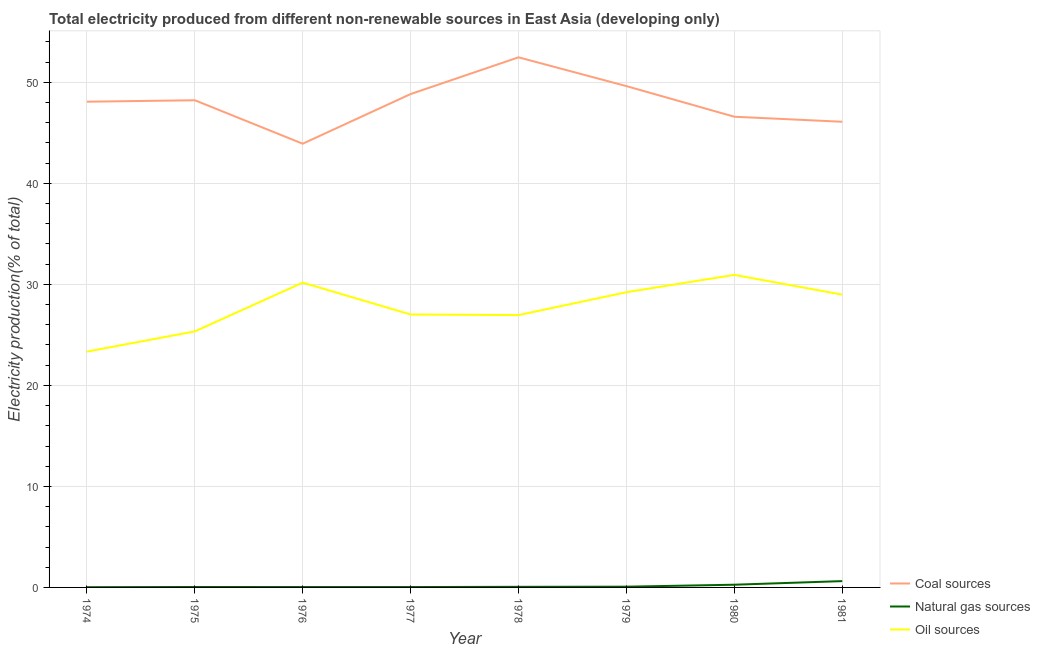Is the number of lines equal to the number of legend labels?
Your answer should be compact. Yes. What is the percentage of electricity produced by natural gas in 1976?
Offer a very short reply. 0.04. Across all years, what is the maximum percentage of electricity produced by coal?
Your answer should be compact. 52.48. Across all years, what is the minimum percentage of electricity produced by coal?
Offer a very short reply. 43.92. In which year was the percentage of electricity produced by natural gas maximum?
Your response must be concise. 1981. In which year was the percentage of electricity produced by natural gas minimum?
Your response must be concise. 1974. What is the total percentage of electricity produced by oil sources in the graph?
Your answer should be compact. 221.99. What is the difference between the percentage of electricity produced by oil sources in 1980 and that in 1981?
Provide a short and direct response. 1.96. What is the difference between the percentage of electricity produced by oil sources in 1981 and the percentage of electricity produced by natural gas in 1974?
Provide a succinct answer. 28.96. What is the average percentage of electricity produced by natural gas per year?
Your answer should be compact. 0.15. In the year 1975, what is the difference between the percentage of electricity produced by natural gas and percentage of electricity produced by coal?
Keep it short and to the point. -48.18. In how many years, is the percentage of electricity produced by natural gas greater than 36 %?
Keep it short and to the point. 0. What is the ratio of the percentage of electricity produced by natural gas in 1974 to that in 1981?
Your response must be concise. 0.04. Is the percentage of electricity produced by natural gas in 1978 less than that in 1979?
Your answer should be compact. Yes. Is the difference between the percentage of electricity produced by natural gas in 1974 and 1975 greater than the difference between the percentage of electricity produced by coal in 1974 and 1975?
Your answer should be very brief. Yes. What is the difference between the highest and the second highest percentage of electricity produced by natural gas?
Offer a very short reply. 0.36. What is the difference between the highest and the lowest percentage of electricity produced by oil sources?
Give a very brief answer. 7.6. In how many years, is the percentage of electricity produced by coal greater than the average percentage of electricity produced by coal taken over all years?
Your response must be concise. 5. Is it the case that in every year, the sum of the percentage of electricity produced by coal and percentage of electricity produced by natural gas is greater than the percentage of electricity produced by oil sources?
Offer a very short reply. Yes. Is the percentage of electricity produced by coal strictly greater than the percentage of electricity produced by oil sources over the years?
Offer a terse response. Yes. Is the percentage of electricity produced by natural gas strictly less than the percentage of electricity produced by coal over the years?
Keep it short and to the point. Yes. How many lines are there?
Your answer should be compact. 3. What is the difference between two consecutive major ticks on the Y-axis?
Keep it short and to the point. 10. Does the graph contain any zero values?
Give a very brief answer. No. Where does the legend appear in the graph?
Ensure brevity in your answer.  Bottom right. How many legend labels are there?
Give a very brief answer. 3. How are the legend labels stacked?
Your answer should be very brief. Vertical. What is the title of the graph?
Your answer should be compact. Total electricity produced from different non-renewable sources in East Asia (developing only). What is the label or title of the X-axis?
Your answer should be very brief. Year. What is the label or title of the Y-axis?
Your response must be concise. Electricity production(% of total). What is the Electricity production(% of total) in Coal sources in 1974?
Offer a terse response. 48.08. What is the Electricity production(% of total) in Natural gas sources in 1974?
Offer a very short reply. 0.02. What is the Electricity production(% of total) of Oil sources in 1974?
Give a very brief answer. 23.34. What is the Electricity production(% of total) of Coal sources in 1975?
Provide a short and direct response. 48.23. What is the Electricity production(% of total) in Natural gas sources in 1975?
Provide a succinct answer. 0.04. What is the Electricity production(% of total) of Oil sources in 1975?
Offer a terse response. 25.34. What is the Electricity production(% of total) in Coal sources in 1976?
Ensure brevity in your answer.  43.92. What is the Electricity production(% of total) in Natural gas sources in 1976?
Provide a short and direct response. 0.04. What is the Electricity production(% of total) in Oil sources in 1976?
Offer a terse response. 30.17. What is the Electricity production(% of total) of Coal sources in 1977?
Make the answer very short. 48.84. What is the Electricity production(% of total) of Natural gas sources in 1977?
Offer a terse response. 0.04. What is the Electricity production(% of total) in Oil sources in 1977?
Ensure brevity in your answer.  27.02. What is the Electricity production(% of total) of Coal sources in 1978?
Make the answer very short. 52.48. What is the Electricity production(% of total) in Natural gas sources in 1978?
Make the answer very short. 0.06. What is the Electricity production(% of total) of Oil sources in 1978?
Offer a very short reply. 26.96. What is the Electricity production(% of total) of Coal sources in 1979?
Keep it short and to the point. 49.63. What is the Electricity production(% of total) of Natural gas sources in 1979?
Your answer should be compact. 0.07. What is the Electricity production(% of total) of Oil sources in 1979?
Ensure brevity in your answer.  29.22. What is the Electricity production(% of total) in Coal sources in 1980?
Ensure brevity in your answer.  46.6. What is the Electricity production(% of total) of Natural gas sources in 1980?
Offer a very short reply. 0.27. What is the Electricity production(% of total) of Oil sources in 1980?
Offer a terse response. 30.94. What is the Electricity production(% of total) of Coal sources in 1981?
Your response must be concise. 46.1. What is the Electricity production(% of total) of Natural gas sources in 1981?
Offer a terse response. 0.62. What is the Electricity production(% of total) in Oil sources in 1981?
Your answer should be very brief. 28.98. Across all years, what is the maximum Electricity production(% of total) in Coal sources?
Make the answer very short. 52.48. Across all years, what is the maximum Electricity production(% of total) in Natural gas sources?
Your answer should be very brief. 0.62. Across all years, what is the maximum Electricity production(% of total) of Oil sources?
Offer a terse response. 30.94. Across all years, what is the minimum Electricity production(% of total) in Coal sources?
Make the answer very short. 43.92. Across all years, what is the minimum Electricity production(% of total) in Natural gas sources?
Keep it short and to the point. 0.02. Across all years, what is the minimum Electricity production(% of total) in Oil sources?
Offer a terse response. 23.34. What is the total Electricity production(% of total) of Coal sources in the graph?
Make the answer very short. 383.87. What is the total Electricity production(% of total) in Natural gas sources in the graph?
Your answer should be very brief. 1.17. What is the total Electricity production(% of total) in Oil sources in the graph?
Offer a very short reply. 221.99. What is the difference between the Electricity production(% of total) of Coal sources in 1974 and that in 1975?
Make the answer very short. -0.14. What is the difference between the Electricity production(% of total) in Natural gas sources in 1974 and that in 1975?
Make the answer very short. -0.02. What is the difference between the Electricity production(% of total) in Oil sources in 1974 and that in 1975?
Provide a succinct answer. -2. What is the difference between the Electricity production(% of total) of Coal sources in 1974 and that in 1976?
Ensure brevity in your answer.  4.16. What is the difference between the Electricity production(% of total) of Natural gas sources in 1974 and that in 1976?
Give a very brief answer. -0.01. What is the difference between the Electricity production(% of total) in Oil sources in 1974 and that in 1976?
Give a very brief answer. -6.83. What is the difference between the Electricity production(% of total) in Coal sources in 1974 and that in 1977?
Provide a short and direct response. -0.76. What is the difference between the Electricity production(% of total) of Natural gas sources in 1974 and that in 1977?
Ensure brevity in your answer.  -0.02. What is the difference between the Electricity production(% of total) of Oil sources in 1974 and that in 1977?
Give a very brief answer. -3.67. What is the difference between the Electricity production(% of total) in Coal sources in 1974 and that in 1978?
Keep it short and to the point. -4.39. What is the difference between the Electricity production(% of total) of Natural gas sources in 1974 and that in 1978?
Offer a very short reply. -0.04. What is the difference between the Electricity production(% of total) of Oil sources in 1974 and that in 1978?
Your answer should be very brief. -3.61. What is the difference between the Electricity production(% of total) in Coal sources in 1974 and that in 1979?
Offer a terse response. -1.54. What is the difference between the Electricity production(% of total) in Natural gas sources in 1974 and that in 1979?
Your response must be concise. -0.05. What is the difference between the Electricity production(% of total) of Oil sources in 1974 and that in 1979?
Provide a succinct answer. -5.88. What is the difference between the Electricity production(% of total) of Coal sources in 1974 and that in 1980?
Your response must be concise. 1.49. What is the difference between the Electricity production(% of total) in Natural gas sources in 1974 and that in 1980?
Make the answer very short. -0.24. What is the difference between the Electricity production(% of total) in Oil sources in 1974 and that in 1980?
Give a very brief answer. -7.6. What is the difference between the Electricity production(% of total) in Coal sources in 1974 and that in 1981?
Your answer should be very brief. 1.98. What is the difference between the Electricity production(% of total) of Natural gas sources in 1974 and that in 1981?
Keep it short and to the point. -0.6. What is the difference between the Electricity production(% of total) in Oil sources in 1974 and that in 1981?
Give a very brief answer. -5.64. What is the difference between the Electricity production(% of total) of Coal sources in 1975 and that in 1976?
Offer a terse response. 4.3. What is the difference between the Electricity production(% of total) of Natural gas sources in 1975 and that in 1976?
Provide a succinct answer. 0.01. What is the difference between the Electricity production(% of total) of Oil sources in 1975 and that in 1976?
Give a very brief answer. -4.83. What is the difference between the Electricity production(% of total) of Coal sources in 1975 and that in 1977?
Provide a succinct answer. -0.61. What is the difference between the Electricity production(% of total) in Natural gas sources in 1975 and that in 1977?
Keep it short and to the point. 0. What is the difference between the Electricity production(% of total) of Oil sources in 1975 and that in 1977?
Your response must be concise. -1.67. What is the difference between the Electricity production(% of total) in Coal sources in 1975 and that in 1978?
Provide a short and direct response. -4.25. What is the difference between the Electricity production(% of total) of Natural gas sources in 1975 and that in 1978?
Make the answer very short. -0.02. What is the difference between the Electricity production(% of total) in Oil sources in 1975 and that in 1978?
Offer a terse response. -1.61. What is the difference between the Electricity production(% of total) in Coal sources in 1975 and that in 1979?
Keep it short and to the point. -1.4. What is the difference between the Electricity production(% of total) in Natural gas sources in 1975 and that in 1979?
Keep it short and to the point. -0.03. What is the difference between the Electricity production(% of total) in Oil sources in 1975 and that in 1979?
Keep it short and to the point. -3.88. What is the difference between the Electricity production(% of total) of Coal sources in 1975 and that in 1980?
Your answer should be very brief. 1.63. What is the difference between the Electricity production(% of total) of Natural gas sources in 1975 and that in 1980?
Your response must be concise. -0.22. What is the difference between the Electricity production(% of total) in Oil sources in 1975 and that in 1980?
Your answer should be very brief. -5.6. What is the difference between the Electricity production(% of total) of Coal sources in 1975 and that in 1981?
Make the answer very short. 2.13. What is the difference between the Electricity production(% of total) in Natural gas sources in 1975 and that in 1981?
Offer a very short reply. -0.58. What is the difference between the Electricity production(% of total) in Oil sources in 1975 and that in 1981?
Provide a succinct answer. -3.64. What is the difference between the Electricity production(% of total) in Coal sources in 1976 and that in 1977?
Offer a terse response. -4.92. What is the difference between the Electricity production(% of total) in Natural gas sources in 1976 and that in 1977?
Give a very brief answer. -0. What is the difference between the Electricity production(% of total) in Oil sources in 1976 and that in 1977?
Your answer should be compact. 3.15. What is the difference between the Electricity production(% of total) of Coal sources in 1976 and that in 1978?
Ensure brevity in your answer.  -8.55. What is the difference between the Electricity production(% of total) in Natural gas sources in 1976 and that in 1978?
Provide a short and direct response. -0.02. What is the difference between the Electricity production(% of total) in Oil sources in 1976 and that in 1978?
Your answer should be compact. 3.21. What is the difference between the Electricity production(% of total) of Coal sources in 1976 and that in 1979?
Offer a terse response. -5.7. What is the difference between the Electricity production(% of total) of Natural gas sources in 1976 and that in 1979?
Ensure brevity in your answer.  -0.04. What is the difference between the Electricity production(% of total) of Oil sources in 1976 and that in 1979?
Offer a terse response. 0.95. What is the difference between the Electricity production(% of total) of Coal sources in 1976 and that in 1980?
Offer a very short reply. -2.67. What is the difference between the Electricity production(% of total) in Natural gas sources in 1976 and that in 1980?
Provide a succinct answer. -0.23. What is the difference between the Electricity production(% of total) in Oil sources in 1976 and that in 1980?
Give a very brief answer. -0.77. What is the difference between the Electricity production(% of total) in Coal sources in 1976 and that in 1981?
Your answer should be compact. -2.17. What is the difference between the Electricity production(% of total) of Natural gas sources in 1976 and that in 1981?
Keep it short and to the point. -0.59. What is the difference between the Electricity production(% of total) in Oil sources in 1976 and that in 1981?
Keep it short and to the point. 1.19. What is the difference between the Electricity production(% of total) of Coal sources in 1977 and that in 1978?
Provide a short and direct response. -3.64. What is the difference between the Electricity production(% of total) of Natural gas sources in 1977 and that in 1978?
Provide a succinct answer. -0.02. What is the difference between the Electricity production(% of total) of Oil sources in 1977 and that in 1978?
Offer a very short reply. 0.06. What is the difference between the Electricity production(% of total) of Coal sources in 1977 and that in 1979?
Provide a succinct answer. -0.78. What is the difference between the Electricity production(% of total) in Natural gas sources in 1977 and that in 1979?
Offer a very short reply. -0.03. What is the difference between the Electricity production(% of total) in Oil sources in 1977 and that in 1979?
Your answer should be compact. -2.21. What is the difference between the Electricity production(% of total) in Coal sources in 1977 and that in 1980?
Your answer should be compact. 2.25. What is the difference between the Electricity production(% of total) in Natural gas sources in 1977 and that in 1980?
Ensure brevity in your answer.  -0.23. What is the difference between the Electricity production(% of total) of Oil sources in 1977 and that in 1980?
Keep it short and to the point. -3.92. What is the difference between the Electricity production(% of total) in Coal sources in 1977 and that in 1981?
Your answer should be compact. 2.74. What is the difference between the Electricity production(% of total) in Natural gas sources in 1977 and that in 1981?
Offer a terse response. -0.59. What is the difference between the Electricity production(% of total) of Oil sources in 1977 and that in 1981?
Your response must be concise. -1.96. What is the difference between the Electricity production(% of total) of Coal sources in 1978 and that in 1979?
Make the answer very short. 2.85. What is the difference between the Electricity production(% of total) of Natural gas sources in 1978 and that in 1979?
Make the answer very short. -0.01. What is the difference between the Electricity production(% of total) of Oil sources in 1978 and that in 1979?
Provide a short and direct response. -2.27. What is the difference between the Electricity production(% of total) of Coal sources in 1978 and that in 1980?
Provide a succinct answer. 5.88. What is the difference between the Electricity production(% of total) in Natural gas sources in 1978 and that in 1980?
Provide a succinct answer. -0.21. What is the difference between the Electricity production(% of total) in Oil sources in 1978 and that in 1980?
Your response must be concise. -3.98. What is the difference between the Electricity production(% of total) of Coal sources in 1978 and that in 1981?
Offer a terse response. 6.38. What is the difference between the Electricity production(% of total) of Natural gas sources in 1978 and that in 1981?
Give a very brief answer. -0.57. What is the difference between the Electricity production(% of total) in Oil sources in 1978 and that in 1981?
Your answer should be compact. -2.02. What is the difference between the Electricity production(% of total) in Coal sources in 1979 and that in 1980?
Make the answer very short. 3.03. What is the difference between the Electricity production(% of total) in Natural gas sources in 1979 and that in 1980?
Provide a short and direct response. -0.19. What is the difference between the Electricity production(% of total) in Oil sources in 1979 and that in 1980?
Provide a succinct answer. -1.72. What is the difference between the Electricity production(% of total) in Coal sources in 1979 and that in 1981?
Ensure brevity in your answer.  3.53. What is the difference between the Electricity production(% of total) in Natural gas sources in 1979 and that in 1981?
Your response must be concise. -0.55. What is the difference between the Electricity production(% of total) in Oil sources in 1979 and that in 1981?
Give a very brief answer. 0.24. What is the difference between the Electricity production(% of total) of Coal sources in 1980 and that in 1981?
Ensure brevity in your answer.  0.5. What is the difference between the Electricity production(% of total) of Natural gas sources in 1980 and that in 1981?
Offer a very short reply. -0.36. What is the difference between the Electricity production(% of total) of Oil sources in 1980 and that in 1981?
Ensure brevity in your answer.  1.96. What is the difference between the Electricity production(% of total) in Coal sources in 1974 and the Electricity production(% of total) in Natural gas sources in 1975?
Make the answer very short. 48.04. What is the difference between the Electricity production(% of total) of Coal sources in 1974 and the Electricity production(% of total) of Oil sources in 1975?
Offer a very short reply. 22.74. What is the difference between the Electricity production(% of total) in Natural gas sources in 1974 and the Electricity production(% of total) in Oil sources in 1975?
Keep it short and to the point. -25.32. What is the difference between the Electricity production(% of total) of Coal sources in 1974 and the Electricity production(% of total) of Natural gas sources in 1976?
Provide a succinct answer. 48.05. What is the difference between the Electricity production(% of total) of Coal sources in 1974 and the Electricity production(% of total) of Oil sources in 1976?
Provide a short and direct response. 17.91. What is the difference between the Electricity production(% of total) in Natural gas sources in 1974 and the Electricity production(% of total) in Oil sources in 1976?
Provide a short and direct response. -30.15. What is the difference between the Electricity production(% of total) of Coal sources in 1974 and the Electricity production(% of total) of Natural gas sources in 1977?
Provide a succinct answer. 48.04. What is the difference between the Electricity production(% of total) of Coal sources in 1974 and the Electricity production(% of total) of Oil sources in 1977?
Keep it short and to the point. 21.06. What is the difference between the Electricity production(% of total) in Natural gas sources in 1974 and the Electricity production(% of total) in Oil sources in 1977?
Offer a terse response. -27. What is the difference between the Electricity production(% of total) in Coal sources in 1974 and the Electricity production(% of total) in Natural gas sources in 1978?
Give a very brief answer. 48.02. What is the difference between the Electricity production(% of total) in Coal sources in 1974 and the Electricity production(% of total) in Oil sources in 1978?
Provide a short and direct response. 21.12. What is the difference between the Electricity production(% of total) of Natural gas sources in 1974 and the Electricity production(% of total) of Oil sources in 1978?
Your answer should be compact. -26.94. What is the difference between the Electricity production(% of total) of Coal sources in 1974 and the Electricity production(% of total) of Natural gas sources in 1979?
Ensure brevity in your answer.  48.01. What is the difference between the Electricity production(% of total) of Coal sources in 1974 and the Electricity production(% of total) of Oil sources in 1979?
Offer a terse response. 18.86. What is the difference between the Electricity production(% of total) of Natural gas sources in 1974 and the Electricity production(% of total) of Oil sources in 1979?
Make the answer very short. -29.2. What is the difference between the Electricity production(% of total) in Coal sources in 1974 and the Electricity production(% of total) in Natural gas sources in 1980?
Provide a short and direct response. 47.82. What is the difference between the Electricity production(% of total) of Coal sources in 1974 and the Electricity production(% of total) of Oil sources in 1980?
Provide a short and direct response. 17.14. What is the difference between the Electricity production(% of total) of Natural gas sources in 1974 and the Electricity production(% of total) of Oil sources in 1980?
Your response must be concise. -30.92. What is the difference between the Electricity production(% of total) in Coal sources in 1974 and the Electricity production(% of total) in Natural gas sources in 1981?
Keep it short and to the point. 47.46. What is the difference between the Electricity production(% of total) in Coal sources in 1974 and the Electricity production(% of total) in Oil sources in 1981?
Your response must be concise. 19.1. What is the difference between the Electricity production(% of total) of Natural gas sources in 1974 and the Electricity production(% of total) of Oil sources in 1981?
Offer a terse response. -28.96. What is the difference between the Electricity production(% of total) of Coal sources in 1975 and the Electricity production(% of total) of Natural gas sources in 1976?
Ensure brevity in your answer.  48.19. What is the difference between the Electricity production(% of total) in Coal sources in 1975 and the Electricity production(% of total) in Oil sources in 1976?
Ensure brevity in your answer.  18.06. What is the difference between the Electricity production(% of total) of Natural gas sources in 1975 and the Electricity production(% of total) of Oil sources in 1976?
Make the answer very short. -30.13. What is the difference between the Electricity production(% of total) in Coal sources in 1975 and the Electricity production(% of total) in Natural gas sources in 1977?
Your response must be concise. 48.19. What is the difference between the Electricity production(% of total) of Coal sources in 1975 and the Electricity production(% of total) of Oil sources in 1977?
Ensure brevity in your answer.  21.21. What is the difference between the Electricity production(% of total) in Natural gas sources in 1975 and the Electricity production(% of total) in Oil sources in 1977?
Keep it short and to the point. -26.98. What is the difference between the Electricity production(% of total) in Coal sources in 1975 and the Electricity production(% of total) in Natural gas sources in 1978?
Your response must be concise. 48.17. What is the difference between the Electricity production(% of total) in Coal sources in 1975 and the Electricity production(% of total) in Oil sources in 1978?
Ensure brevity in your answer.  21.27. What is the difference between the Electricity production(% of total) of Natural gas sources in 1975 and the Electricity production(% of total) of Oil sources in 1978?
Provide a short and direct response. -26.92. What is the difference between the Electricity production(% of total) in Coal sources in 1975 and the Electricity production(% of total) in Natural gas sources in 1979?
Your answer should be compact. 48.15. What is the difference between the Electricity production(% of total) of Coal sources in 1975 and the Electricity production(% of total) of Oil sources in 1979?
Ensure brevity in your answer.  19. What is the difference between the Electricity production(% of total) of Natural gas sources in 1975 and the Electricity production(% of total) of Oil sources in 1979?
Ensure brevity in your answer.  -29.18. What is the difference between the Electricity production(% of total) of Coal sources in 1975 and the Electricity production(% of total) of Natural gas sources in 1980?
Your answer should be compact. 47.96. What is the difference between the Electricity production(% of total) in Coal sources in 1975 and the Electricity production(% of total) in Oil sources in 1980?
Offer a terse response. 17.29. What is the difference between the Electricity production(% of total) of Natural gas sources in 1975 and the Electricity production(% of total) of Oil sources in 1980?
Keep it short and to the point. -30.9. What is the difference between the Electricity production(% of total) of Coal sources in 1975 and the Electricity production(% of total) of Natural gas sources in 1981?
Make the answer very short. 47.6. What is the difference between the Electricity production(% of total) in Coal sources in 1975 and the Electricity production(% of total) in Oil sources in 1981?
Provide a short and direct response. 19.24. What is the difference between the Electricity production(% of total) of Natural gas sources in 1975 and the Electricity production(% of total) of Oil sources in 1981?
Provide a succinct answer. -28.94. What is the difference between the Electricity production(% of total) in Coal sources in 1976 and the Electricity production(% of total) in Natural gas sources in 1977?
Provide a short and direct response. 43.89. What is the difference between the Electricity production(% of total) of Coal sources in 1976 and the Electricity production(% of total) of Oil sources in 1977?
Give a very brief answer. 16.9. What is the difference between the Electricity production(% of total) of Natural gas sources in 1976 and the Electricity production(% of total) of Oil sources in 1977?
Give a very brief answer. -26.98. What is the difference between the Electricity production(% of total) in Coal sources in 1976 and the Electricity production(% of total) in Natural gas sources in 1978?
Ensure brevity in your answer.  43.87. What is the difference between the Electricity production(% of total) in Coal sources in 1976 and the Electricity production(% of total) in Oil sources in 1978?
Ensure brevity in your answer.  16.97. What is the difference between the Electricity production(% of total) in Natural gas sources in 1976 and the Electricity production(% of total) in Oil sources in 1978?
Keep it short and to the point. -26.92. What is the difference between the Electricity production(% of total) in Coal sources in 1976 and the Electricity production(% of total) in Natural gas sources in 1979?
Make the answer very short. 43.85. What is the difference between the Electricity production(% of total) in Coal sources in 1976 and the Electricity production(% of total) in Oil sources in 1979?
Make the answer very short. 14.7. What is the difference between the Electricity production(% of total) of Natural gas sources in 1976 and the Electricity production(% of total) of Oil sources in 1979?
Ensure brevity in your answer.  -29.19. What is the difference between the Electricity production(% of total) of Coal sources in 1976 and the Electricity production(% of total) of Natural gas sources in 1980?
Your answer should be very brief. 43.66. What is the difference between the Electricity production(% of total) of Coal sources in 1976 and the Electricity production(% of total) of Oil sources in 1980?
Keep it short and to the point. 12.98. What is the difference between the Electricity production(% of total) of Natural gas sources in 1976 and the Electricity production(% of total) of Oil sources in 1980?
Offer a terse response. -30.9. What is the difference between the Electricity production(% of total) in Coal sources in 1976 and the Electricity production(% of total) in Natural gas sources in 1981?
Offer a terse response. 43.3. What is the difference between the Electricity production(% of total) of Coal sources in 1976 and the Electricity production(% of total) of Oil sources in 1981?
Your answer should be very brief. 14.94. What is the difference between the Electricity production(% of total) of Natural gas sources in 1976 and the Electricity production(% of total) of Oil sources in 1981?
Give a very brief answer. -28.95. What is the difference between the Electricity production(% of total) in Coal sources in 1977 and the Electricity production(% of total) in Natural gas sources in 1978?
Offer a terse response. 48.78. What is the difference between the Electricity production(% of total) of Coal sources in 1977 and the Electricity production(% of total) of Oil sources in 1978?
Provide a succinct answer. 21.88. What is the difference between the Electricity production(% of total) of Natural gas sources in 1977 and the Electricity production(% of total) of Oil sources in 1978?
Keep it short and to the point. -26.92. What is the difference between the Electricity production(% of total) of Coal sources in 1977 and the Electricity production(% of total) of Natural gas sources in 1979?
Provide a succinct answer. 48.77. What is the difference between the Electricity production(% of total) of Coal sources in 1977 and the Electricity production(% of total) of Oil sources in 1979?
Give a very brief answer. 19.62. What is the difference between the Electricity production(% of total) of Natural gas sources in 1977 and the Electricity production(% of total) of Oil sources in 1979?
Offer a very short reply. -29.19. What is the difference between the Electricity production(% of total) of Coal sources in 1977 and the Electricity production(% of total) of Natural gas sources in 1980?
Your answer should be compact. 48.57. What is the difference between the Electricity production(% of total) of Coal sources in 1977 and the Electricity production(% of total) of Oil sources in 1980?
Keep it short and to the point. 17.9. What is the difference between the Electricity production(% of total) of Natural gas sources in 1977 and the Electricity production(% of total) of Oil sources in 1980?
Provide a succinct answer. -30.9. What is the difference between the Electricity production(% of total) in Coal sources in 1977 and the Electricity production(% of total) in Natural gas sources in 1981?
Offer a terse response. 48.22. What is the difference between the Electricity production(% of total) of Coal sources in 1977 and the Electricity production(% of total) of Oil sources in 1981?
Your answer should be very brief. 19.86. What is the difference between the Electricity production(% of total) in Natural gas sources in 1977 and the Electricity production(% of total) in Oil sources in 1981?
Your answer should be compact. -28.94. What is the difference between the Electricity production(% of total) in Coal sources in 1978 and the Electricity production(% of total) in Natural gas sources in 1979?
Your response must be concise. 52.4. What is the difference between the Electricity production(% of total) in Coal sources in 1978 and the Electricity production(% of total) in Oil sources in 1979?
Your answer should be compact. 23.25. What is the difference between the Electricity production(% of total) of Natural gas sources in 1978 and the Electricity production(% of total) of Oil sources in 1979?
Make the answer very short. -29.17. What is the difference between the Electricity production(% of total) in Coal sources in 1978 and the Electricity production(% of total) in Natural gas sources in 1980?
Your response must be concise. 52.21. What is the difference between the Electricity production(% of total) of Coal sources in 1978 and the Electricity production(% of total) of Oil sources in 1980?
Ensure brevity in your answer.  21.54. What is the difference between the Electricity production(% of total) in Natural gas sources in 1978 and the Electricity production(% of total) in Oil sources in 1980?
Ensure brevity in your answer.  -30.88. What is the difference between the Electricity production(% of total) in Coal sources in 1978 and the Electricity production(% of total) in Natural gas sources in 1981?
Provide a short and direct response. 51.85. What is the difference between the Electricity production(% of total) of Coal sources in 1978 and the Electricity production(% of total) of Oil sources in 1981?
Offer a terse response. 23.49. What is the difference between the Electricity production(% of total) of Natural gas sources in 1978 and the Electricity production(% of total) of Oil sources in 1981?
Your answer should be very brief. -28.92. What is the difference between the Electricity production(% of total) in Coal sources in 1979 and the Electricity production(% of total) in Natural gas sources in 1980?
Offer a terse response. 49.36. What is the difference between the Electricity production(% of total) of Coal sources in 1979 and the Electricity production(% of total) of Oil sources in 1980?
Offer a very short reply. 18.69. What is the difference between the Electricity production(% of total) in Natural gas sources in 1979 and the Electricity production(% of total) in Oil sources in 1980?
Make the answer very short. -30.87. What is the difference between the Electricity production(% of total) in Coal sources in 1979 and the Electricity production(% of total) in Natural gas sources in 1981?
Keep it short and to the point. 49. What is the difference between the Electricity production(% of total) in Coal sources in 1979 and the Electricity production(% of total) in Oil sources in 1981?
Offer a very short reply. 20.64. What is the difference between the Electricity production(% of total) in Natural gas sources in 1979 and the Electricity production(% of total) in Oil sources in 1981?
Keep it short and to the point. -28.91. What is the difference between the Electricity production(% of total) in Coal sources in 1980 and the Electricity production(% of total) in Natural gas sources in 1981?
Your response must be concise. 45.97. What is the difference between the Electricity production(% of total) of Coal sources in 1980 and the Electricity production(% of total) of Oil sources in 1981?
Make the answer very short. 17.61. What is the difference between the Electricity production(% of total) of Natural gas sources in 1980 and the Electricity production(% of total) of Oil sources in 1981?
Give a very brief answer. -28.72. What is the average Electricity production(% of total) of Coal sources per year?
Your answer should be compact. 47.98. What is the average Electricity production(% of total) in Natural gas sources per year?
Offer a very short reply. 0.15. What is the average Electricity production(% of total) of Oil sources per year?
Offer a very short reply. 27.75. In the year 1974, what is the difference between the Electricity production(% of total) of Coal sources and Electricity production(% of total) of Natural gas sources?
Your response must be concise. 48.06. In the year 1974, what is the difference between the Electricity production(% of total) of Coal sources and Electricity production(% of total) of Oil sources?
Offer a very short reply. 24.74. In the year 1974, what is the difference between the Electricity production(% of total) of Natural gas sources and Electricity production(% of total) of Oil sources?
Provide a succinct answer. -23.32. In the year 1975, what is the difference between the Electricity production(% of total) in Coal sources and Electricity production(% of total) in Natural gas sources?
Offer a terse response. 48.18. In the year 1975, what is the difference between the Electricity production(% of total) of Coal sources and Electricity production(% of total) of Oil sources?
Offer a terse response. 22.88. In the year 1975, what is the difference between the Electricity production(% of total) in Natural gas sources and Electricity production(% of total) in Oil sources?
Your answer should be very brief. -25.3. In the year 1976, what is the difference between the Electricity production(% of total) of Coal sources and Electricity production(% of total) of Natural gas sources?
Give a very brief answer. 43.89. In the year 1976, what is the difference between the Electricity production(% of total) of Coal sources and Electricity production(% of total) of Oil sources?
Keep it short and to the point. 13.75. In the year 1976, what is the difference between the Electricity production(% of total) in Natural gas sources and Electricity production(% of total) in Oil sources?
Keep it short and to the point. -30.14. In the year 1977, what is the difference between the Electricity production(% of total) in Coal sources and Electricity production(% of total) in Natural gas sources?
Make the answer very short. 48.8. In the year 1977, what is the difference between the Electricity production(% of total) of Coal sources and Electricity production(% of total) of Oil sources?
Give a very brief answer. 21.82. In the year 1977, what is the difference between the Electricity production(% of total) in Natural gas sources and Electricity production(% of total) in Oil sources?
Make the answer very short. -26.98. In the year 1978, what is the difference between the Electricity production(% of total) in Coal sources and Electricity production(% of total) in Natural gas sources?
Give a very brief answer. 52.42. In the year 1978, what is the difference between the Electricity production(% of total) of Coal sources and Electricity production(% of total) of Oil sources?
Ensure brevity in your answer.  25.52. In the year 1978, what is the difference between the Electricity production(% of total) in Natural gas sources and Electricity production(% of total) in Oil sources?
Offer a very short reply. -26.9. In the year 1979, what is the difference between the Electricity production(% of total) of Coal sources and Electricity production(% of total) of Natural gas sources?
Your answer should be compact. 49.55. In the year 1979, what is the difference between the Electricity production(% of total) of Coal sources and Electricity production(% of total) of Oil sources?
Make the answer very short. 20.4. In the year 1979, what is the difference between the Electricity production(% of total) in Natural gas sources and Electricity production(% of total) in Oil sources?
Provide a short and direct response. -29.15. In the year 1980, what is the difference between the Electricity production(% of total) in Coal sources and Electricity production(% of total) in Natural gas sources?
Offer a terse response. 46.33. In the year 1980, what is the difference between the Electricity production(% of total) in Coal sources and Electricity production(% of total) in Oil sources?
Give a very brief answer. 15.65. In the year 1980, what is the difference between the Electricity production(% of total) in Natural gas sources and Electricity production(% of total) in Oil sources?
Provide a succinct answer. -30.67. In the year 1981, what is the difference between the Electricity production(% of total) of Coal sources and Electricity production(% of total) of Natural gas sources?
Offer a terse response. 45.47. In the year 1981, what is the difference between the Electricity production(% of total) of Coal sources and Electricity production(% of total) of Oil sources?
Keep it short and to the point. 17.12. In the year 1981, what is the difference between the Electricity production(% of total) of Natural gas sources and Electricity production(% of total) of Oil sources?
Make the answer very short. -28.36. What is the ratio of the Electricity production(% of total) in Natural gas sources in 1974 to that in 1975?
Offer a very short reply. 0.54. What is the ratio of the Electricity production(% of total) in Oil sources in 1974 to that in 1975?
Provide a succinct answer. 0.92. What is the ratio of the Electricity production(% of total) in Coal sources in 1974 to that in 1976?
Your answer should be compact. 1.09. What is the ratio of the Electricity production(% of total) in Natural gas sources in 1974 to that in 1976?
Your answer should be very brief. 0.63. What is the ratio of the Electricity production(% of total) in Oil sources in 1974 to that in 1976?
Offer a terse response. 0.77. What is the ratio of the Electricity production(% of total) of Coal sources in 1974 to that in 1977?
Your response must be concise. 0.98. What is the ratio of the Electricity production(% of total) of Natural gas sources in 1974 to that in 1977?
Ensure brevity in your answer.  0.61. What is the ratio of the Electricity production(% of total) of Oil sources in 1974 to that in 1977?
Your response must be concise. 0.86. What is the ratio of the Electricity production(% of total) of Coal sources in 1974 to that in 1978?
Offer a very short reply. 0.92. What is the ratio of the Electricity production(% of total) of Natural gas sources in 1974 to that in 1978?
Ensure brevity in your answer.  0.4. What is the ratio of the Electricity production(% of total) in Oil sources in 1974 to that in 1978?
Offer a terse response. 0.87. What is the ratio of the Electricity production(% of total) in Coal sources in 1974 to that in 1979?
Provide a short and direct response. 0.97. What is the ratio of the Electricity production(% of total) of Natural gas sources in 1974 to that in 1979?
Provide a succinct answer. 0.32. What is the ratio of the Electricity production(% of total) in Oil sources in 1974 to that in 1979?
Offer a terse response. 0.8. What is the ratio of the Electricity production(% of total) of Coal sources in 1974 to that in 1980?
Offer a very short reply. 1.03. What is the ratio of the Electricity production(% of total) in Natural gas sources in 1974 to that in 1980?
Make the answer very short. 0.09. What is the ratio of the Electricity production(% of total) in Oil sources in 1974 to that in 1980?
Offer a very short reply. 0.75. What is the ratio of the Electricity production(% of total) in Coal sources in 1974 to that in 1981?
Offer a terse response. 1.04. What is the ratio of the Electricity production(% of total) of Natural gas sources in 1974 to that in 1981?
Ensure brevity in your answer.  0.04. What is the ratio of the Electricity production(% of total) of Oil sources in 1974 to that in 1981?
Your answer should be very brief. 0.81. What is the ratio of the Electricity production(% of total) of Coal sources in 1975 to that in 1976?
Give a very brief answer. 1.1. What is the ratio of the Electricity production(% of total) in Natural gas sources in 1975 to that in 1976?
Give a very brief answer. 1.16. What is the ratio of the Electricity production(% of total) in Oil sources in 1975 to that in 1976?
Provide a short and direct response. 0.84. What is the ratio of the Electricity production(% of total) of Coal sources in 1975 to that in 1977?
Your response must be concise. 0.99. What is the ratio of the Electricity production(% of total) in Natural gas sources in 1975 to that in 1977?
Offer a terse response. 1.12. What is the ratio of the Electricity production(% of total) of Oil sources in 1975 to that in 1977?
Provide a short and direct response. 0.94. What is the ratio of the Electricity production(% of total) of Coal sources in 1975 to that in 1978?
Your response must be concise. 0.92. What is the ratio of the Electricity production(% of total) of Natural gas sources in 1975 to that in 1978?
Keep it short and to the point. 0.73. What is the ratio of the Electricity production(% of total) in Oil sources in 1975 to that in 1978?
Your response must be concise. 0.94. What is the ratio of the Electricity production(% of total) of Coal sources in 1975 to that in 1979?
Keep it short and to the point. 0.97. What is the ratio of the Electricity production(% of total) of Natural gas sources in 1975 to that in 1979?
Make the answer very short. 0.59. What is the ratio of the Electricity production(% of total) in Oil sources in 1975 to that in 1979?
Your response must be concise. 0.87. What is the ratio of the Electricity production(% of total) of Coal sources in 1975 to that in 1980?
Ensure brevity in your answer.  1.03. What is the ratio of the Electricity production(% of total) of Natural gas sources in 1975 to that in 1980?
Keep it short and to the point. 0.16. What is the ratio of the Electricity production(% of total) of Oil sources in 1975 to that in 1980?
Offer a terse response. 0.82. What is the ratio of the Electricity production(% of total) of Coal sources in 1975 to that in 1981?
Your answer should be compact. 1.05. What is the ratio of the Electricity production(% of total) of Natural gas sources in 1975 to that in 1981?
Ensure brevity in your answer.  0.07. What is the ratio of the Electricity production(% of total) in Oil sources in 1975 to that in 1981?
Provide a succinct answer. 0.87. What is the ratio of the Electricity production(% of total) in Coal sources in 1976 to that in 1977?
Your response must be concise. 0.9. What is the ratio of the Electricity production(% of total) in Oil sources in 1976 to that in 1977?
Ensure brevity in your answer.  1.12. What is the ratio of the Electricity production(% of total) of Coal sources in 1976 to that in 1978?
Offer a terse response. 0.84. What is the ratio of the Electricity production(% of total) of Natural gas sources in 1976 to that in 1978?
Provide a succinct answer. 0.63. What is the ratio of the Electricity production(% of total) in Oil sources in 1976 to that in 1978?
Offer a terse response. 1.12. What is the ratio of the Electricity production(% of total) of Coal sources in 1976 to that in 1979?
Provide a succinct answer. 0.89. What is the ratio of the Electricity production(% of total) in Natural gas sources in 1976 to that in 1979?
Make the answer very short. 0.51. What is the ratio of the Electricity production(% of total) of Oil sources in 1976 to that in 1979?
Offer a very short reply. 1.03. What is the ratio of the Electricity production(% of total) in Coal sources in 1976 to that in 1980?
Your answer should be compact. 0.94. What is the ratio of the Electricity production(% of total) in Natural gas sources in 1976 to that in 1980?
Ensure brevity in your answer.  0.14. What is the ratio of the Electricity production(% of total) of Oil sources in 1976 to that in 1980?
Make the answer very short. 0.98. What is the ratio of the Electricity production(% of total) of Coal sources in 1976 to that in 1981?
Offer a terse response. 0.95. What is the ratio of the Electricity production(% of total) in Natural gas sources in 1976 to that in 1981?
Make the answer very short. 0.06. What is the ratio of the Electricity production(% of total) in Oil sources in 1976 to that in 1981?
Your answer should be very brief. 1.04. What is the ratio of the Electricity production(% of total) in Coal sources in 1977 to that in 1978?
Make the answer very short. 0.93. What is the ratio of the Electricity production(% of total) in Natural gas sources in 1977 to that in 1978?
Your answer should be very brief. 0.65. What is the ratio of the Electricity production(% of total) of Coal sources in 1977 to that in 1979?
Offer a terse response. 0.98. What is the ratio of the Electricity production(% of total) of Natural gas sources in 1977 to that in 1979?
Offer a very short reply. 0.53. What is the ratio of the Electricity production(% of total) of Oil sources in 1977 to that in 1979?
Make the answer very short. 0.92. What is the ratio of the Electricity production(% of total) of Coal sources in 1977 to that in 1980?
Offer a terse response. 1.05. What is the ratio of the Electricity production(% of total) in Natural gas sources in 1977 to that in 1980?
Keep it short and to the point. 0.14. What is the ratio of the Electricity production(% of total) of Oil sources in 1977 to that in 1980?
Keep it short and to the point. 0.87. What is the ratio of the Electricity production(% of total) in Coal sources in 1977 to that in 1981?
Your answer should be very brief. 1.06. What is the ratio of the Electricity production(% of total) in Natural gas sources in 1977 to that in 1981?
Make the answer very short. 0.06. What is the ratio of the Electricity production(% of total) in Oil sources in 1977 to that in 1981?
Give a very brief answer. 0.93. What is the ratio of the Electricity production(% of total) in Coal sources in 1978 to that in 1979?
Make the answer very short. 1.06. What is the ratio of the Electricity production(% of total) of Natural gas sources in 1978 to that in 1979?
Keep it short and to the point. 0.8. What is the ratio of the Electricity production(% of total) in Oil sources in 1978 to that in 1979?
Your answer should be very brief. 0.92. What is the ratio of the Electricity production(% of total) of Coal sources in 1978 to that in 1980?
Offer a very short reply. 1.13. What is the ratio of the Electricity production(% of total) in Natural gas sources in 1978 to that in 1980?
Your response must be concise. 0.22. What is the ratio of the Electricity production(% of total) of Oil sources in 1978 to that in 1980?
Ensure brevity in your answer.  0.87. What is the ratio of the Electricity production(% of total) in Coal sources in 1978 to that in 1981?
Offer a very short reply. 1.14. What is the ratio of the Electricity production(% of total) of Natural gas sources in 1978 to that in 1981?
Your response must be concise. 0.09. What is the ratio of the Electricity production(% of total) in Oil sources in 1978 to that in 1981?
Your answer should be very brief. 0.93. What is the ratio of the Electricity production(% of total) of Coal sources in 1979 to that in 1980?
Your answer should be compact. 1.06. What is the ratio of the Electricity production(% of total) in Natural gas sources in 1979 to that in 1980?
Your answer should be compact. 0.27. What is the ratio of the Electricity production(% of total) in Oil sources in 1979 to that in 1980?
Provide a short and direct response. 0.94. What is the ratio of the Electricity production(% of total) in Coal sources in 1979 to that in 1981?
Offer a very short reply. 1.08. What is the ratio of the Electricity production(% of total) in Natural gas sources in 1979 to that in 1981?
Keep it short and to the point. 0.12. What is the ratio of the Electricity production(% of total) in Oil sources in 1979 to that in 1981?
Offer a terse response. 1.01. What is the ratio of the Electricity production(% of total) in Coal sources in 1980 to that in 1981?
Give a very brief answer. 1.01. What is the ratio of the Electricity production(% of total) of Natural gas sources in 1980 to that in 1981?
Your answer should be very brief. 0.43. What is the ratio of the Electricity production(% of total) of Oil sources in 1980 to that in 1981?
Offer a very short reply. 1.07. What is the difference between the highest and the second highest Electricity production(% of total) of Coal sources?
Keep it short and to the point. 2.85. What is the difference between the highest and the second highest Electricity production(% of total) in Natural gas sources?
Offer a terse response. 0.36. What is the difference between the highest and the second highest Electricity production(% of total) in Oil sources?
Your response must be concise. 0.77. What is the difference between the highest and the lowest Electricity production(% of total) in Coal sources?
Your answer should be very brief. 8.55. What is the difference between the highest and the lowest Electricity production(% of total) of Natural gas sources?
Give a very brief answer. 0.6. What is the difference between the highest and the lowest Electricity production(% of total) of Oil sources?
Offer a very short reply. 7.6. 